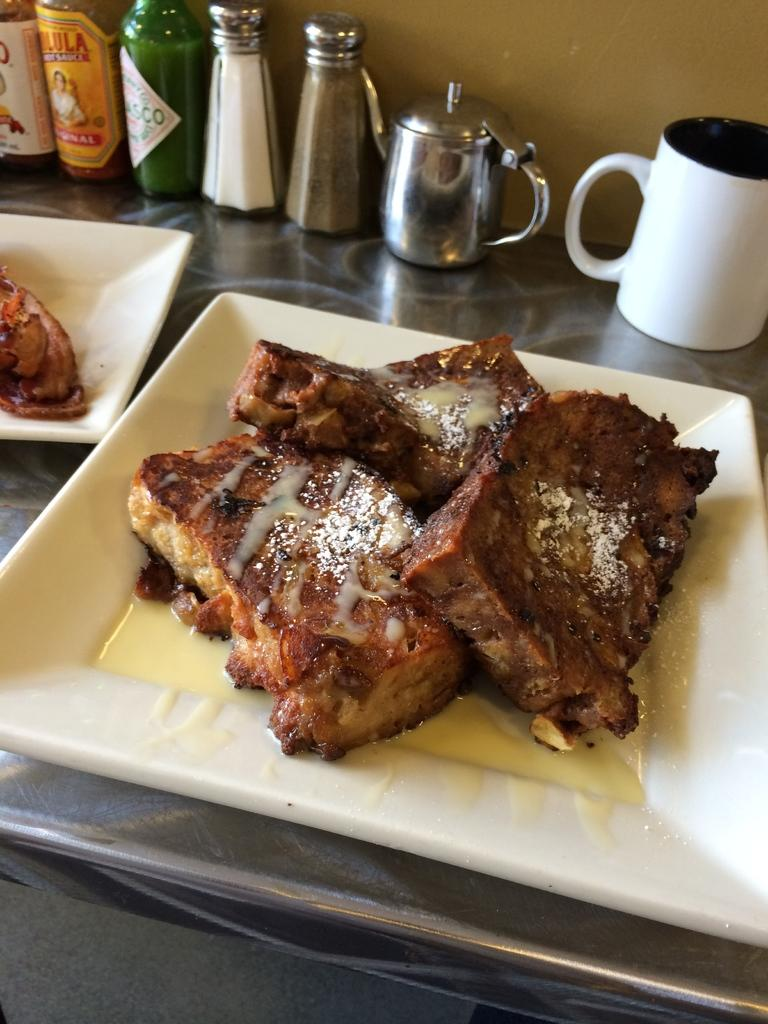How many plates are visible in the image? There are two white plates in the image. What is on the plates? There is food on the plates. What type of container is present for holding a beverage? There is a cup in the image. What condiments are available in the image? There is a salt bottle and a black pepper bottle in the image. What type of kitchen appliance is visible in the image? There is a steel kettle in the image. What type of shoes can be seen in the image? There are no shoes present in the image. What is the lead content of the food on the plates? The provided facts do not mention the lead content of the food, and it is not possible to determine this from the image. 